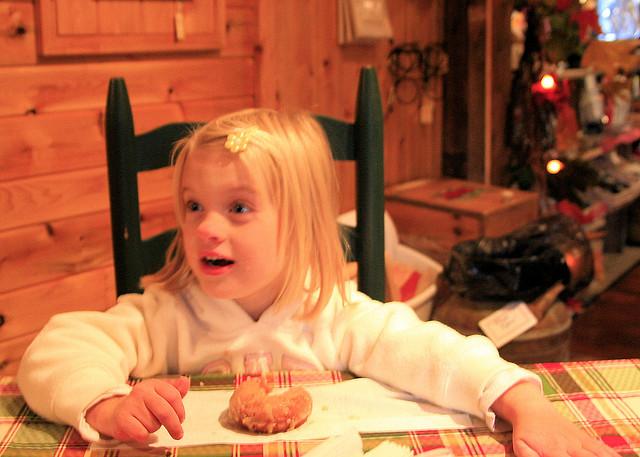How old is the girl?
Be succinct. 6. Is the tablecloth plaid?
Write a very short answer. Yes. What is girl eating?
Quick response, please. Doughnut. 